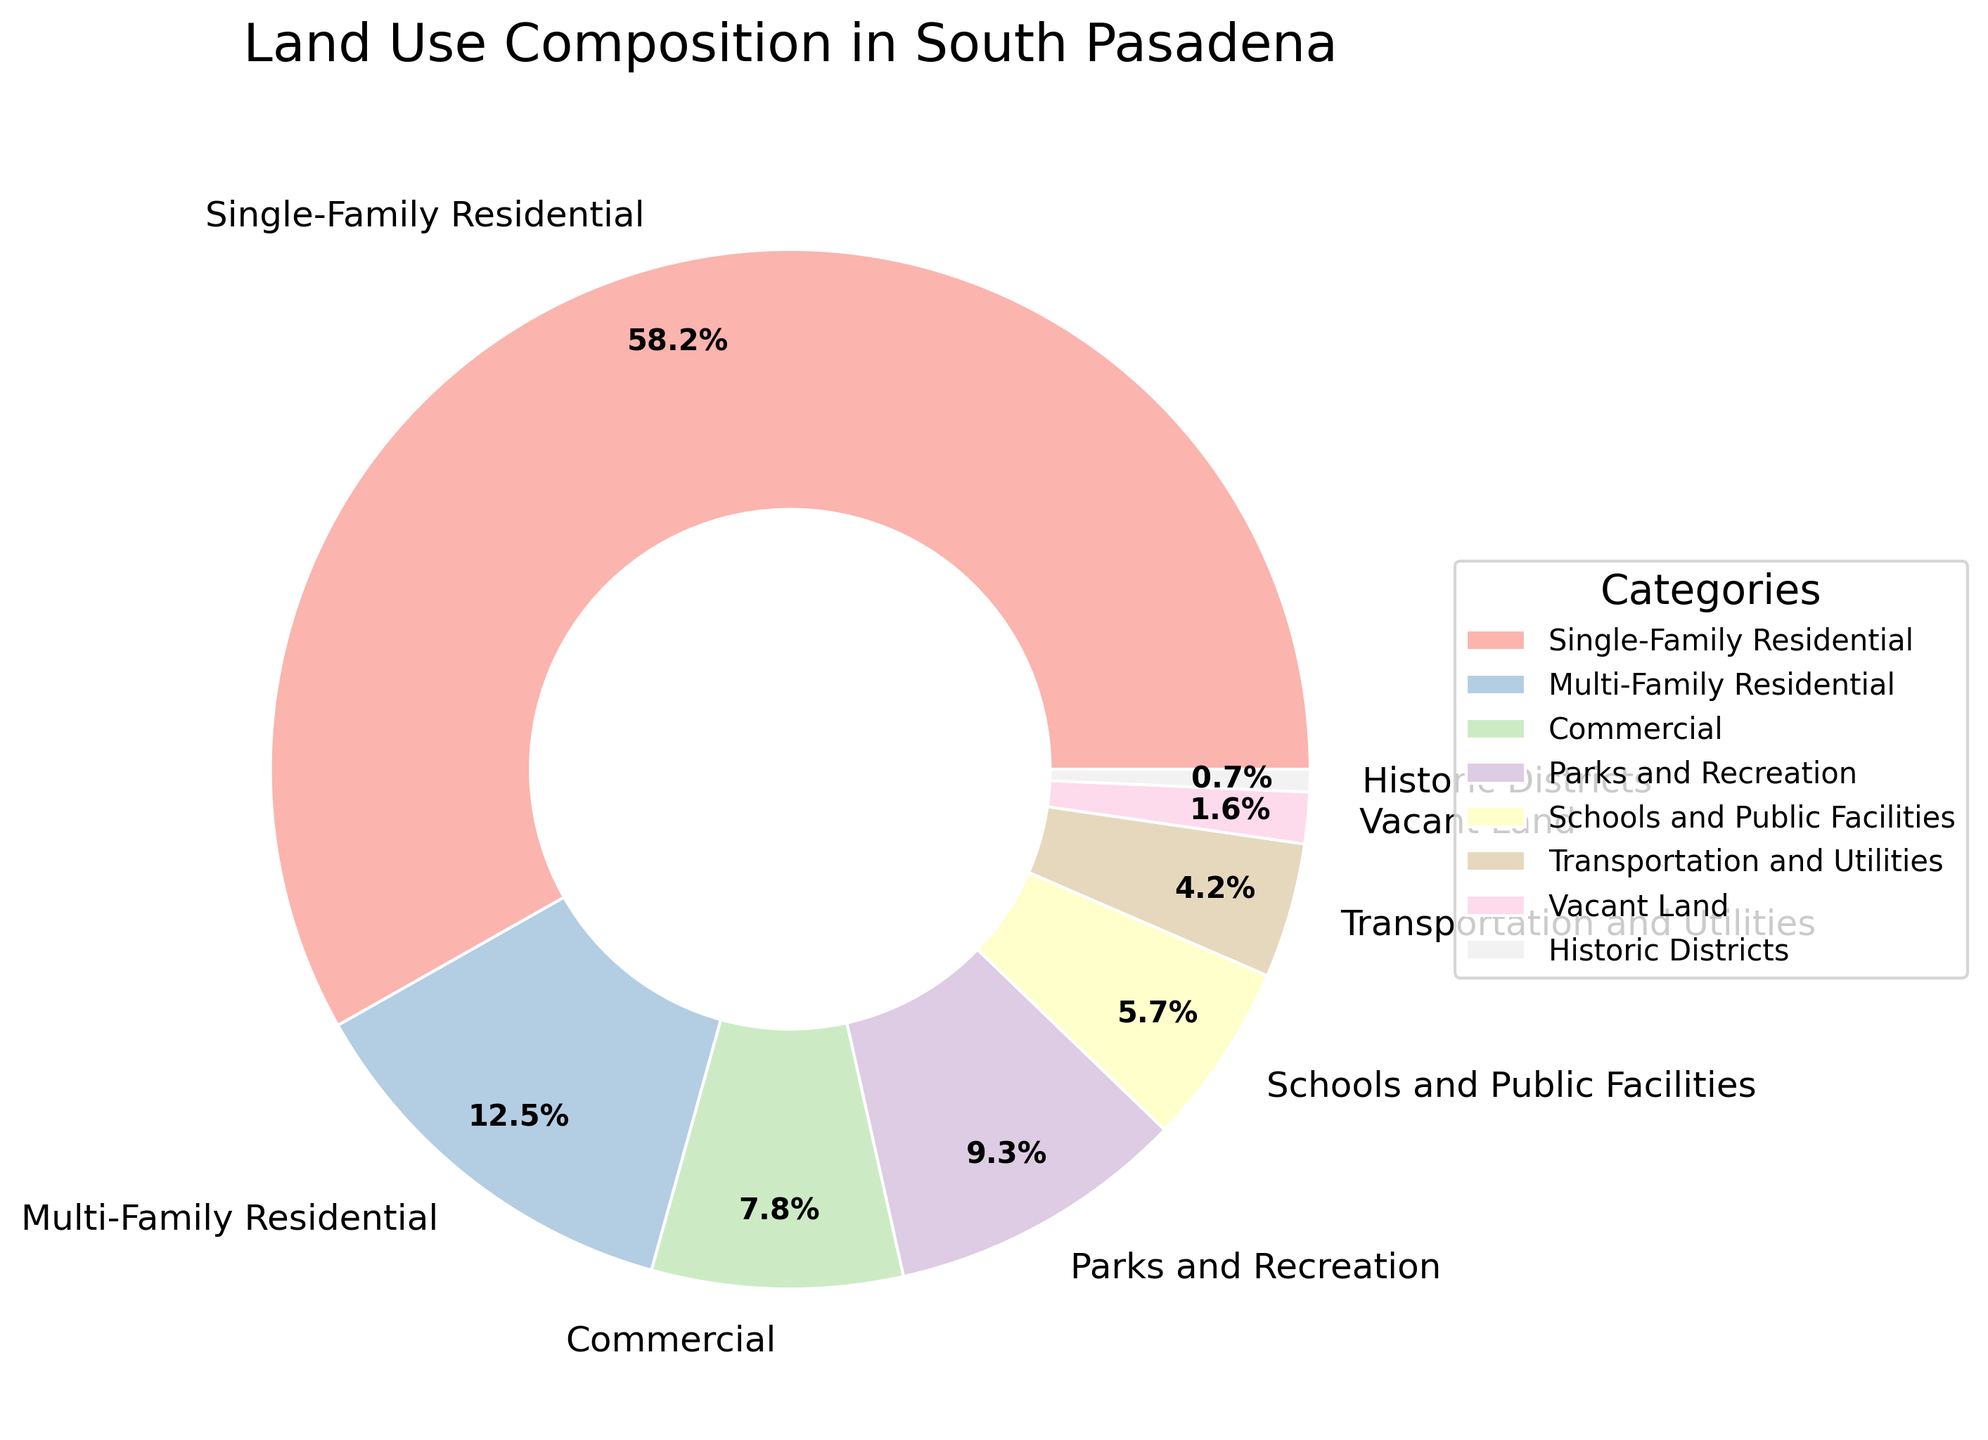What is the combined percentage of Single-Family and Multi-Family Residential land use? The Single-Family Residential percentage is 58.2%, and the Multi-Family Residential percentage is 12.5%. Adding these together, the combined percentage is 58.2 + 12.5 = 70.7%
Answer: 70.7% Which category occupies the least amount of land in South Pasadena? We look at the percentages for each category and find that Historic Districts have the smallest percentage at 0.7%
Answer: Historic Districts How much more land is used for Parks and Recreation compared to Vacant Land? The percentage for Parks and Recreation is 9.3%, and for Vacant Land, it is 1.6%. Subtracting these, 9.3 - 1.6 = 7.7% more land is used for Parks and Recreation
Answer: 7.7% Which category of land use is the second largest? The largest category is Single-Family Residential at 58.2%. The next largest percentage is Multi-Family Residential at 12.5%
Answer: Multi-Family Residential Is the percentage of land used for schools and public facilities greater than or less than the percentage used for transportation and utilities? The percentage for Schools and Public Facilities is 5.7%, while for Transportation and Utilities, it is 4.2%. Since 5.7 is greater than 4.2, Schools and Public Facilities use more land
Answer: Greater What is the total percentage of land used for non-residential purposes (Commercial, Parks and Recreation, Schools and Public Facilities, Transportation and Utilities, Vacant Land, Historic Districts)? Summing the percentages for these categories: 7.8 + 9.3 + 5.7 + 4.2 + 1.6 + 0.7 = 29.3%
Answer: 29.3% Is the proportion of land used for Single-Family Residential land more than double that of Multi-Family Residential? Single-Family Residential is 58.2%, and double Multi-Family Residential would be 12.5 * 2 = 25%. Since 58.2 > 25, Single-Family Residential is more than double
Answer: Yes How does the percentage of Commercial land compare to Parks and Recreation land? The percentage for Commercial land is 7.8%, whereas for Parks and Recreation, it is 9.3%. Since 9.3 > 7.8, Parks and Recreation has a higher percentage than Commercial
Answer: Parks and Recreation has more What visual features distinguish the category with the highest percentage of land use? The category with the highest percentage is Single-Family Residential. Visually, it occupies the largest wedge in the pie chart, likely positioned prominently, and labeled with the largest percentage (58.2%)
Answer: Largest wedge, labeled 58.2% 